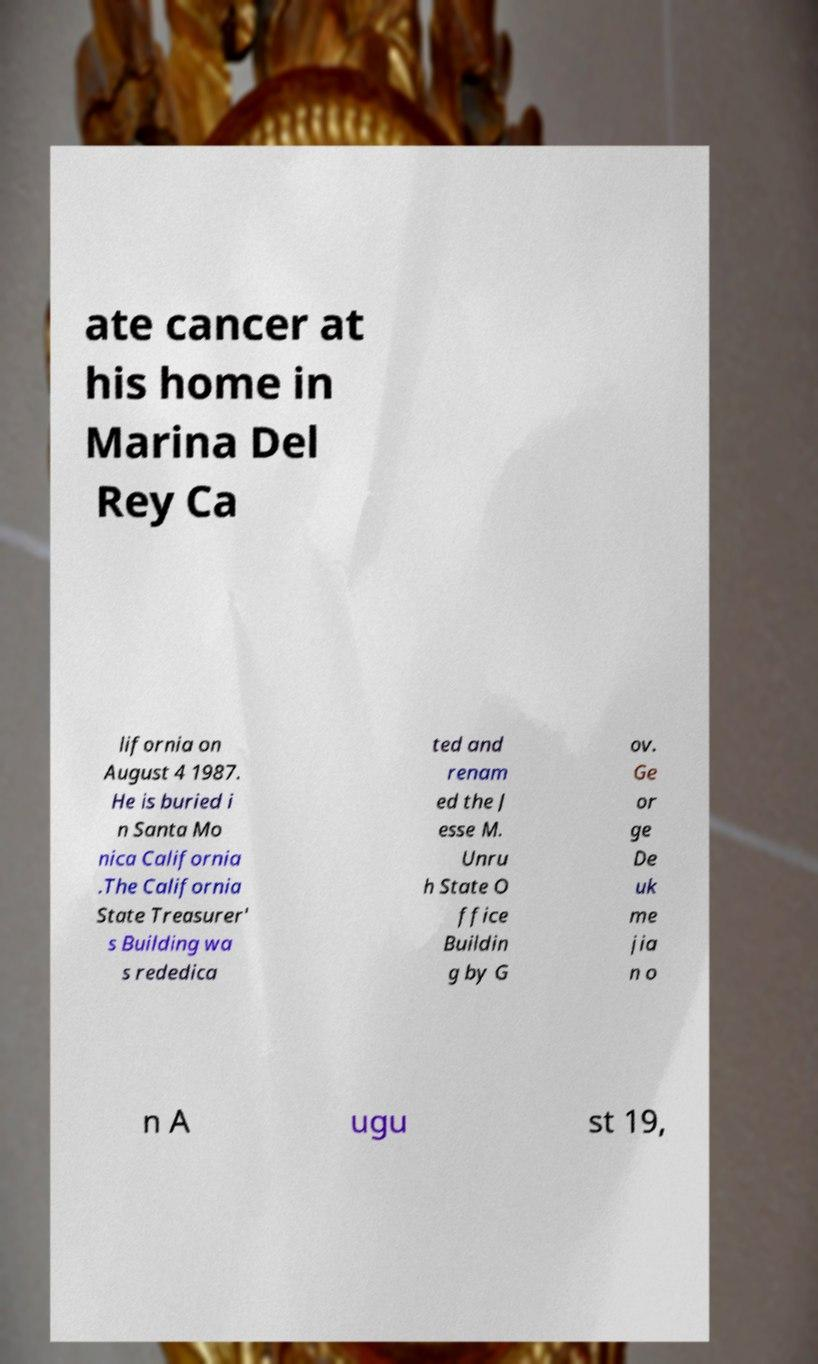Please identify and transcribe the text found in this image. ate cancer at his home in Marina Del Rey Ca lifornia on August 4 1987. He is buried i n Santa Mo nica California .The California State Treasurer' s Building wa s rededica ted and renam ed the J esse M. Unru h State O ffice Buildin g by G ov. Ge or ge De uk me jia n o n A ugu st 19, 